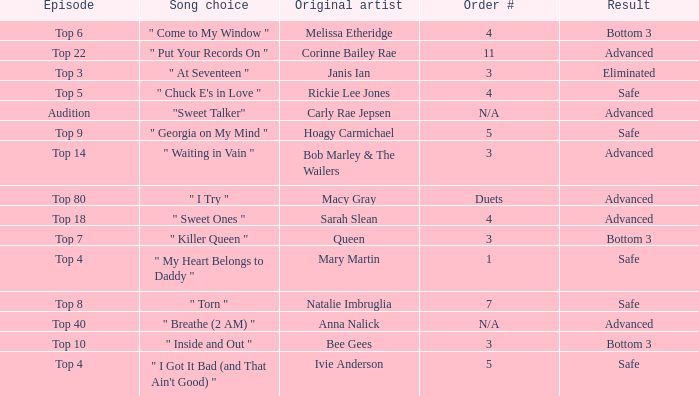What's the order number of the song originally performed by Rickie Lee Jones? 4.0. 